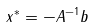Convert formula to latex. <formula><loc_0><loc_0><loc_500><loc_500>x ^ { * } = - A ^ { - 1 } b</formula> 